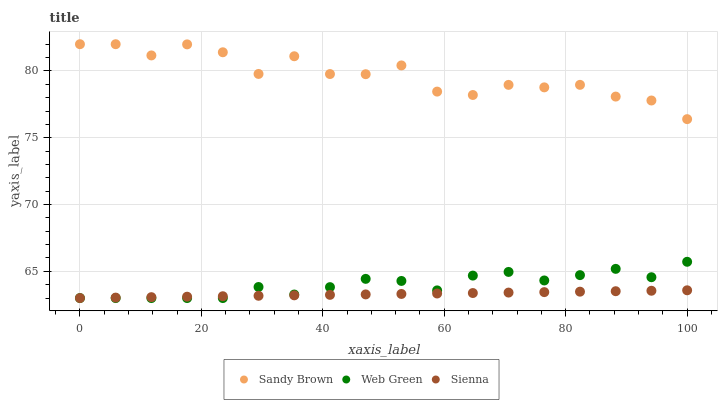Does Sienna have the minimum area under the curve?
Answer yes or no. Yes. Does Sandy Brown have the maximum area under the curve?
Answer yes or no. Yes. Does Web Green have the minimum area under the curve?
Answer yes or no. No. Does Web Green have the maximum area under the curve?
Answer yes or no. No. Is Sienna the smoothest?
Answer yes or no. Yes. Is Sandy Brown the roughest?
Answer yes or no. Yes. Is Web Green the smoothest?
Answer yes or no. No. Is Web Green the roughest?
Answer yes or no. No. Does Sienna have the lowest value?
Answer yes or no. Yes. Does Sandy Brown have the lowest value?
Answer yes or no. No. Does Sandy Brown have the highest value?
Answer yes or no. Yes. Does Web Green have the highest value?
Answer yes or no. No. Is Sienna less than Sandy Brown?
Answer yes or no. Yes. Is Sandy Brown greater than Web Green?
Answer yes or no. Yes. Does Sienna intersect Web Green?
Answer yes or no. Yes. Is Sienna less than Web Green?
Answer yes or no. No. Is Sienna greater than Web Green?
Answer yes or no. No. Does Sienna intersect Sandy Brown?
Answer yes or no. No. 